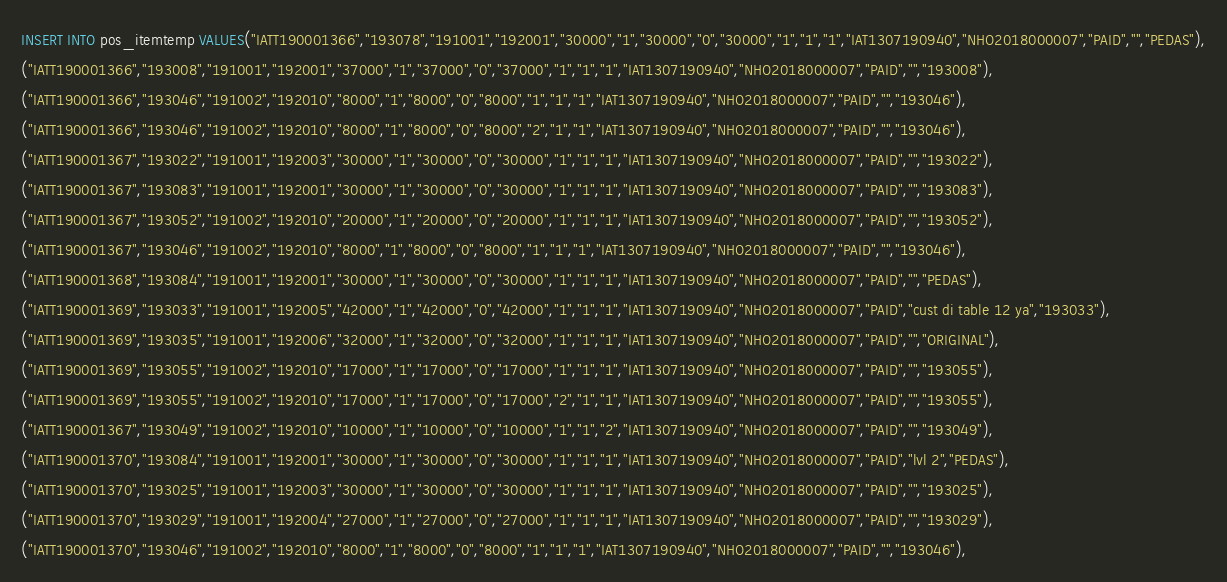Convert code to text. <code><loc_0><loc_0><loc_500><loc_500><_SQL_>INSERT INTO pos_itemtemp VALUES("IATT190001366","193078","191001","192001","30000","1","30000","0","30000","1","1","1","IAT1307190940","NHO2018000007","PAID","","PEDAS"),
("IATT190001366","193008","191001","192001","37000","1","37000","0","37000","1","1","1","IAT1307190940","NHO2018000007","PAID","","193008"),
("IATT190001366","193046","191002","192010","8000","1","8000","0","8000","1","1","1","IAT1307190940","NHO2018000007","PAID","","193046"),
("IATT190001366","193046","191002","192010","8000","1","8000","0","8000","2","1","1","IAT1307190940","NHO2018000007","PAID","","193046"),
("IATT190001367","193022","191001","192003","30000","1","30000","0","30000","1","1","1","IAT1307190940","NHO2018000007","PAID","","193022"),
("IATT190001367","193083","191001","192001","30000","1","30000","0","30000","1","1","1","IAT1307190940","NHO2018000007","PAID","","193083"),
("IATT190001367","193052","191002","192010","20000","1","20000","0","20000","1","1","1","IAT1307190940","NHO2018000007","PAID","","193052"),
("IATT190001367","193046","191002","192010","8000","1","8000","0","8000","1","1","1","IAT1307190940","NHO2018000007","PAID","","193046"),
("IATT190001368","193084","191001","192001","30000","1","30000","0","30000","1","1","1","IAT1307190940","NHO2018000007","PAID","","PEDAS"),
("IATT190001369","193033","191001","192005","42000","1","42000","0","42000","1","1","1","IAT1307190940","NHO2018000007","PAID","cust di table 12 ya","193033"),
("IATT190001369","193035","191001","192006","32000","1","32000","0","32000","1","1","1","IAT1307190940","NHO2018000007","PAID","","ORIGINAL"),
("IATT190001369","193055","191002","192010","17000","1","17000","0","17000","1","1","1","IAT1307190940","NHO2018000007","PAID","","193055"),
("IATT190001369","193055","191002","192010","17000","1","17000","0","17000","2","1","1","IAT1307190940","NHO2018000007","PAID","","193055"),
("IATT190001367","193049","191002","192010","10000","1","10000","0","10000","1","1","2","IAT1307190940","NHO2018000007","PAID","","193049"),
("IATT190001370","193084","191001","192001","30000","1","30000","0","30000","1","1","1","IAT1307190940","NHO2018000007","PAID","lvl 2","PEDAS"),
("IATT190001370","193025","191001","192003","30000","1","30000","0","30000","1","1","1","IAT1307190940","NHO2018000007","PAID","","193025"),
("IATT190001370","193029","191001","192004","27000","1","27000","0","27000","1","1","1","IAT1307190940","NHO2018000007","PAID","","193029"),
("IATT190001370","193046","191002","192010","8000","1","8000","0","8000","1","1","1","IAT1307190940","NHO2018000007","PAID","","193046"),</code> 